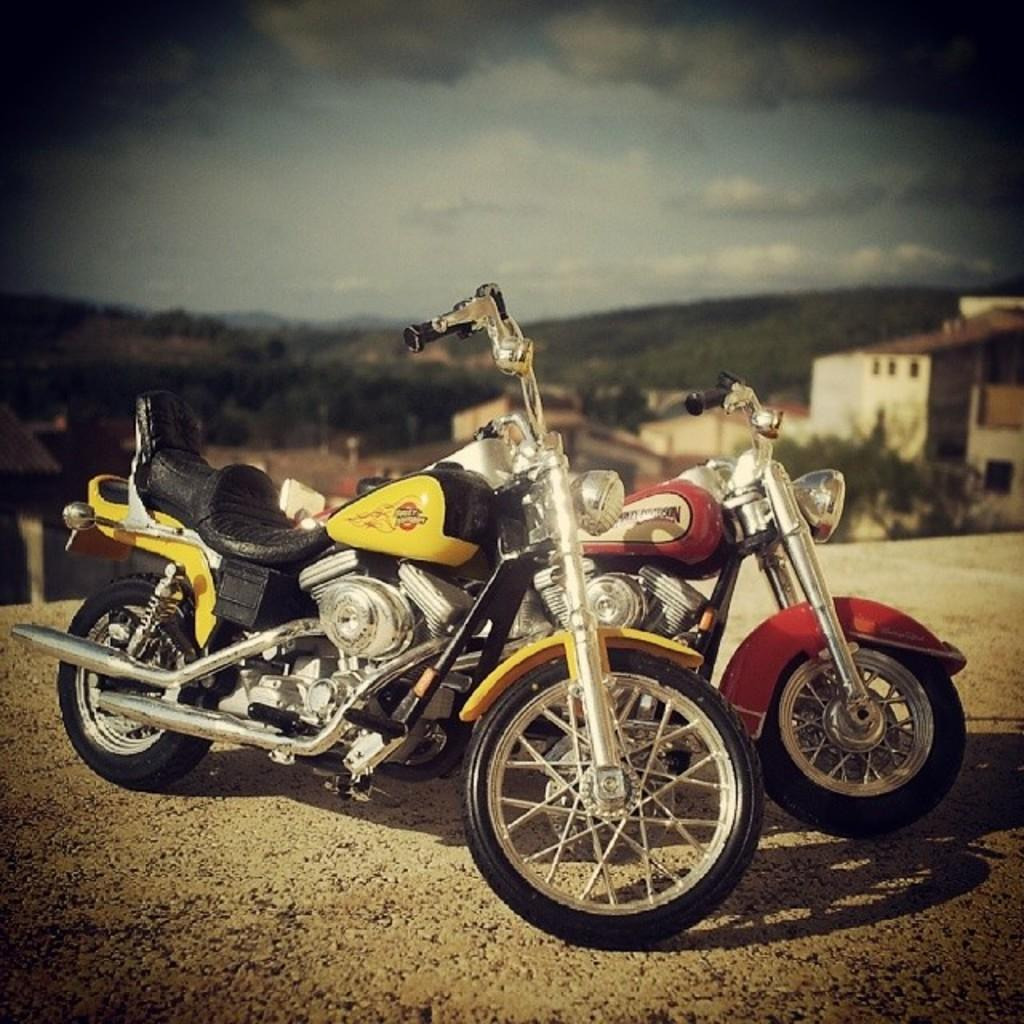What can be seen on the path in the image? There are two bikes on the path in the image. How would you describe the background of the image? The background of the image has a blurred view, with hills, trees, houses, and a cloudy sky visible. What language is the mom speaking to her pet in the image? There is no mom or pet present in the image, so it is not possible to determine what language they might be speaking. 